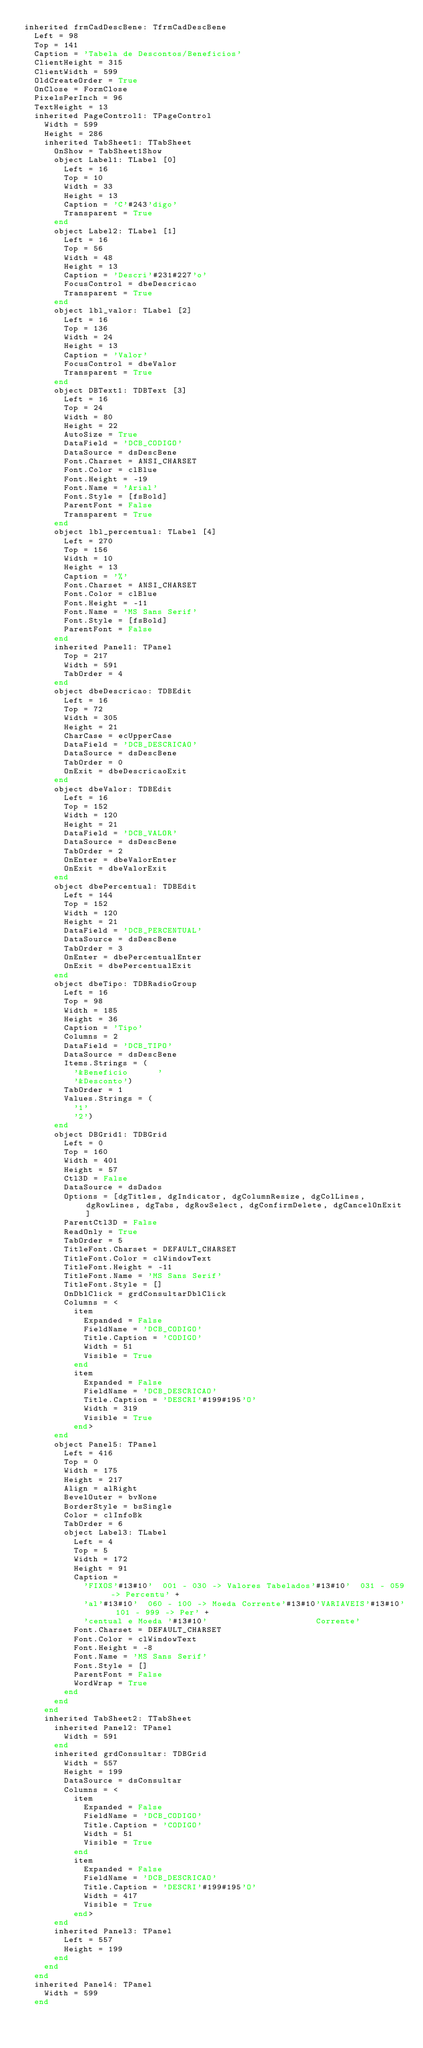<code> <loc_0><loc_0><loc_500><loc_500><_Pascal_>inherited frmCadDescBene: TfrmCadDescBene
  Left = 98
  Top = 141
  Caption = 'Tabela de Descontos/Beneficios'
  ClientHeight = 315
  ClientWidth = 599
  OldCreateOrder = True
  OnClose = FormClose
  PixelsPerInch = 96
  TextHeight = 13
  inherited PageControl1: TPageControl
    Width = 599
    Height = 286
    inherited TabSheet1: TTabSheet
      OnShow = TabSheet1Show
      object Label1: TLabel [0]
        Left = 16
        Top = 10
        Width = 33
        Height = 13
        Caption = 'C'#243'digo'
        Transparent = True
      end
      object Label2: TLabel [1]
        Left = 16
        Top = 56
        Width = 48
        Height = 13
        Caption = 'Descri'#231#227'o'
        FocusControl = dbeDescricao
        Transparent = True
      end
      object lbl_valor: TLabel [2]
        Left = 16
        Top = 136
        Width = 24
        Height = 13
        Caption = 'Valor'
        FocusControl = dbeValor
        Transparent = True
      end
      object DBText1: TDBText [3]
        Left = 16
        Top = 24
        Width = 80
        Height = 22
        AutoSize = True
        DataField = 'DCB_CODIGO'
        DataSource = dsDescBene
        Font.Charset = ANSI_CHARSET
        Font.Color = clBlue
        Font.Height = -19
        Font.Name = 'Arial'
        Font.Style = [fsBold]
        ParentFont = False
        Transparent = True
      end
      object lbl_percentual: TLabel [4]
        Left = 270
        Top = 156
        Width = 10
        Height = 13
        Caption = '%'
        Font.Charset = ANSI_CHARSET
        Font.Color = clBlue
        Font.Height = -11
        Font.Name = 'MS Sans Serif'
        Font.Style = [fsBold]
        ParentFont = False
      end
      inherited Panel1: TPanel
        Top = 217
        Width = 591
        TabOrder = 4
      end
      object dbeDescricao: TDBEdit
        Left = 16
        Top = 72
        Width = 305
        Height = 21
        CharCase = ecUpperCase
        DataField = 'DCB_DESCRICAO'
        DataSource = dsDescBene
        TabOrder = 0
        OnExit = dbeDescricaoExit
      end
      object dbeValor: TDBEdit
        Left = 16
        Top = 152
        Width = 120
        Height = 21
        DataField = 'DCB_VALOR'
        DataSource = dsDescBene
        TabOrder = 2
        OnEnter = dbeValorEnter
        OnExit = dbeValorExit
      end
      object dbePercentual: TDBEdit
        Left = 144
        Top = 152
        Width = 120
        Height = 21
        DataField = 'DCB_PERCENTUAL'
        DataSource = dsDescBene
        TabOrder = 3
        OnEnter = dbePercentualEnter
        OnExit = dbePercentualExit
      end
      object dbeTipo: TDBRadioGroup
        Left = 16
        Top = 98
        Width = 185
        Height = 36
        Caption = 'Tipo'
        Columns = 2
        DataField = 'DCB_TIPO'
        DataSource = dsDescBene
        Items.Strings = (
          '&Beneficio      '
          '&Desconto')
        TabOrder = 1
        Values.Strings = (
          '1'
          '2')
      end
      object DBGrid1: TDBGrid
        Left = 0
        Top = 160
        Width = 401
        Height = 57
        Ctl3D = False
        DataSource = dsDados
        Options = [dgTitles, dgIndicator, dgColumnResize, dgColLines, dgRowLines, dgTabs, dgRowSelect, dgConfirmDelete, dgCancelOnExit]
        ParentCtl3D = False
        ReadOnly = True
        TabOrder = 5
        TitleFont.Charset = DEFAULT_CHARSET
        TitleFont.Color = clWindowText
        TitleFont.Height = -11
        TitleFont.Name = 'MS Sans Serif'
        TitleFont.Style = []
        OnDblClick = grdConsultarDblClick
        Columns = <
          item
            Expanded = False
            FieldName = 'DCB_CODIGO'
            Title.Caption = 'CODIGO'
            Width = 51
            Visible = True
          end
          item
            Expanded = False
            FieldName = 'DCB_DESCRICAO'
            Title.Caption = 'DESCRI'#199#195'O'
            Width = 319
            Visible = True
          end>
      end
      object Panel5: TPanel
        Left = 416
        Top = 0
        Width = 175
        Height = 217
        Align = alRight
        BevelOuter = bvNone
        BorderStyle = bsSingle
        Color = clInfoBk
        TabOrder = 6
        object Label3: TLabel
          Left = 4
          Top = 5
          Width = 172
          Height = 91
          Caption = 
            'FIXOS'#13#10'  001 - 030 -> Valores Tabelados'#13#10'  031 - 059 -> Percentu' +
            'al'#13#10'  060 - 100 -> Moeda Corrente'#13#10'VARIAVEIS'#13#10'  101 - 999 -> Per' +
            'centual e Moeda '#13#10'                      Corrente'
          Font.Charset = DEFAULT_CHARSET
          Font.Color = clWindowText
          Font.Height = -8
          Font.Name = 'MS Sans Serif'
          Font.Style = []
          ParentFont = False
          WordWrap = True
        end
      end
    end
    inherited TabSheet2: TTabSheet
      inherited Panel2: TPanel
        Width = 591
      end
      inherited grdConsultar: TDBGrid
        Width = 557
        Height = 199
        DataSource = dsConsultar
        Columns = <
          item
            Expanded = False
            FieldName = 'DCB_CODIGO'
            Title.Caption = 'CODIGO'
            Width = 51
            Visible = True
          end
          item
            Expanded = False
            FieldName = 'DCB_DESCRICAO'
            Title.Caption = 'DESCRI'#199#195'O'
            Width = 417
            Visible = True
          end>
      end
      inherited Panel3: TPanel
        Left = 557
        Height = 199
      end
    end
  end
  inherited Panel4: TPanel
    Width = 599
  end</code> 